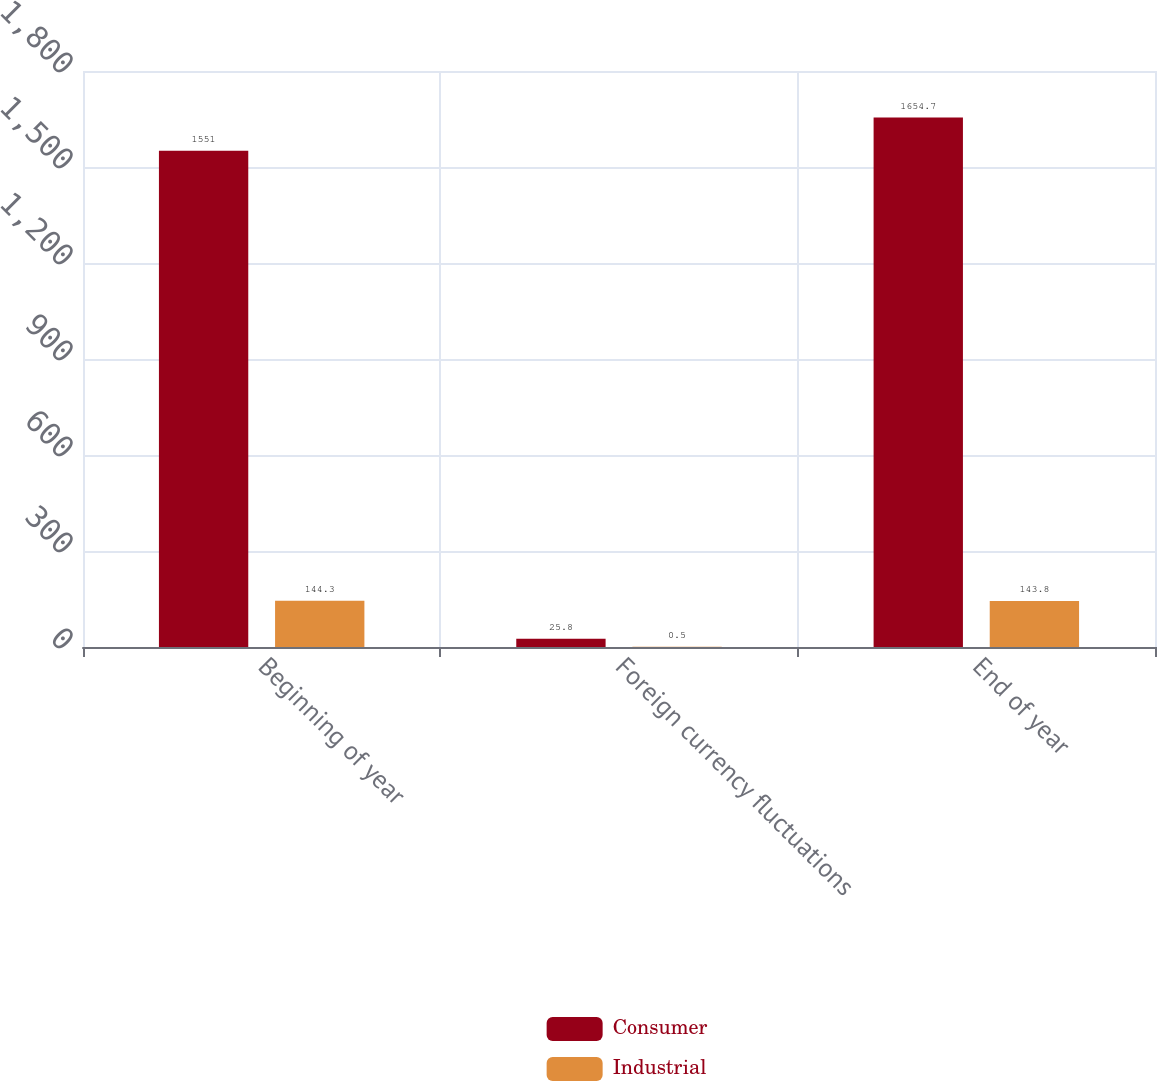Convert chart to OTSL. <chart><loc_0><loc_0><loc_500><loc_500><stacked_bar_chart><ecel><fcel>Beginning of year<fcel>Foreign currency fluctuations<fcel>End of year<nl><fcel>Consumer<fcel>1551<fcel>25.8<fcel>1654.7<nl><fcel>Industrial<fcel>144.3<fcel>0.5<fcel>143.8<nl></chart> 